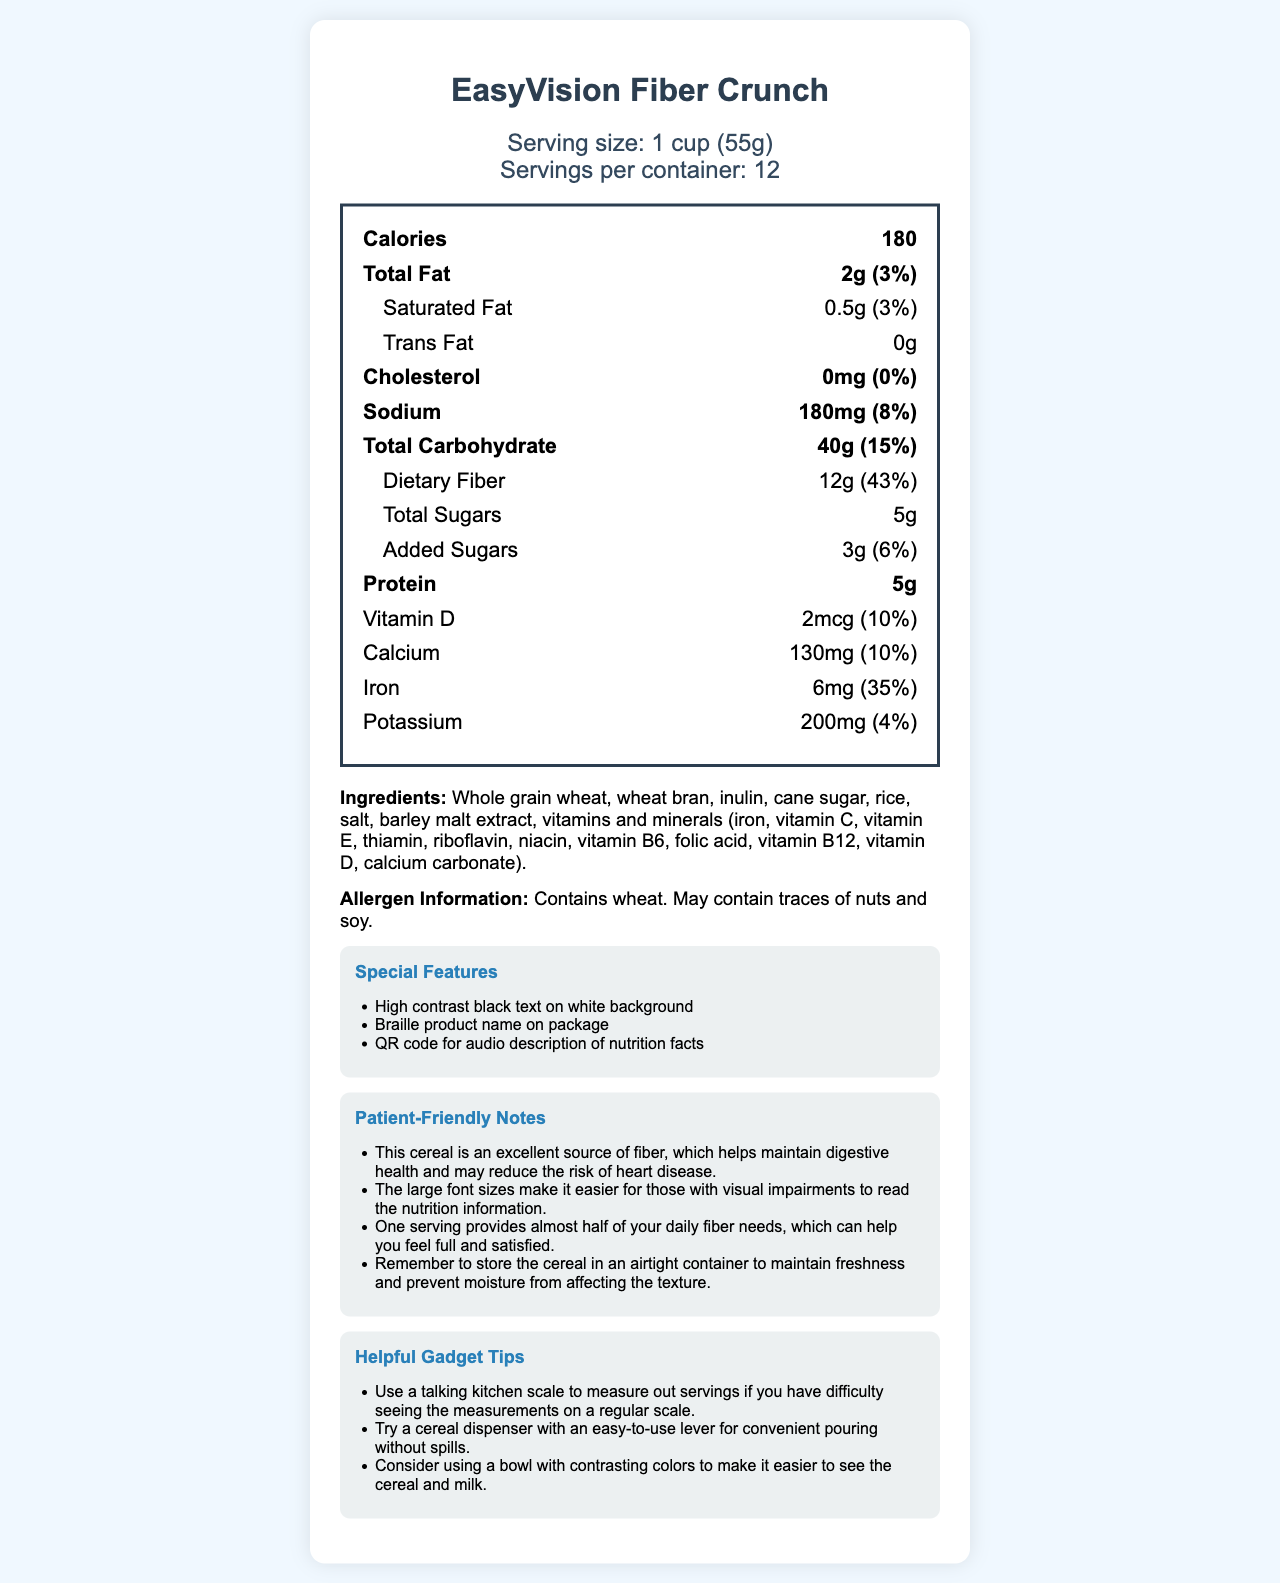what is the serving size of EasyVision Fiber Crunch? The serving size is listed as "1 cup (55g)" in the serving information section of the document.
Answer: 1 cup (55g) how much dietary fiber is in one serving? The document states that one serving contains 12g of dietary fiber in the nutrition facts section.
Answer: 12g what is the percentage daily value (%DV) for protein? The %DV for protein is not listed in the provided nutrition information of the document.
Answer: Not provided what are the total carbohydrates in one serving? The total carbohydrates content per serving is 40g as shown in the nutrition facts section.
Answer: 40g what is the total fat content in one serving? The total fat content per serving is listed as 2g in the nutrition facts section.
Answer: 2g how many servings are in the entire container? A. 10 B. 12 C. 14 The serving information section mentions that there are 12 servings per container.
Answer: B. 12 which of the following vitamins is mentioned in the ingredients list? I. Vitamin A II. Vitamin B6 III. Vitamin K The ingredients list includes vitamins and minerals such as Vitamin B6, but does not mention Vitamin A or Vitamin K.
Answer: II. Vitamin B6 is there any trans fat in this cereal? The nutrition facts section indicates that the trans fat content is 0g; hence, there is no trans fat.
Answer: No does this product contain any allergens? The allergen information mentions that the product contains wheat and may contain traces of nuts and soy.
Answer: Yes describe the special features included in the document. The document provides multiple accessibility features including large fonts, high contrast text, a Braille product name, and an audio description QR code to assist individuals with visual impairments.
Answer: EasyVision Fiber Crunch has several special features designed for visually impaired individuals. The document includes large, easy-to-read font sizes, a high contrast black text on white background, Braille product name on the package, and a QR code for an audio description of nutrition facts. what is the main idea of the document? The document aims to present comprehensive information about EasyVision Fiber Crunch's nutritional value, accessibility features for the visually impaired, and helpful tips for storage and usage, catering to a wide range of users including those with visual impairments.
Answer: The document provides detailed nutrition information, ingredients, allergen info, special features, patient-friendly notes, and gadget tips for EasyVision Fiber Crunch, a fiber-rich cereal. It highlights the cereal's nutritional benefits, accessibility features, and additional tips for usage and storage. how much cholesterol does one serving contain? According to the nutrition facts section, one serving contains 0mg of cholesterol.
Answer: 0mg is the %DV for iron higher than that of calcium? The %DV for iron is 35%, while the %DV for calcium is 10%; thus, the %DV for iron is higher.
Answer: Yes can we determine the total number of calories for the entire container? We know the calories per serving are 180, but the document does not explicitly state the total number of calories for the entire container. To determine this, we would need to multiply the calories per serving by the total number of servings, which is not directly mentioned in the document.
Answer: No 